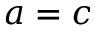<formula> <loc_0><loc_0><loc_500><loc_500>a = c</formula> 